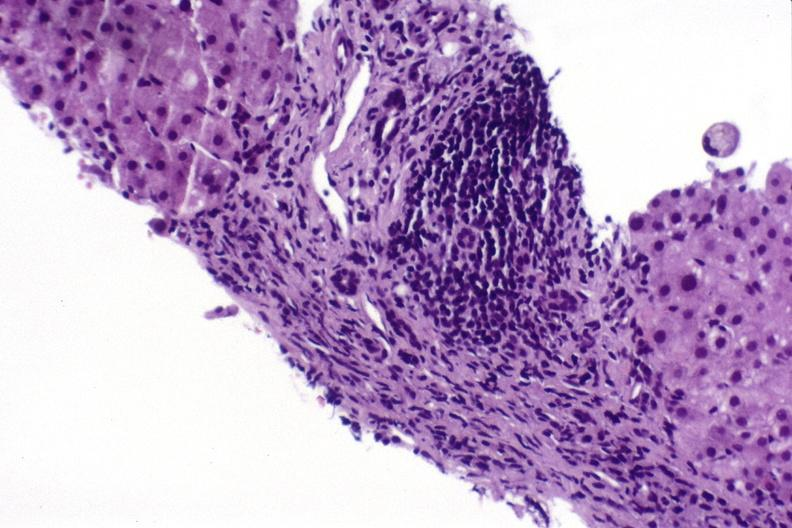what is present?
Answer the question using a single word or phrase. Hepatobiliary 